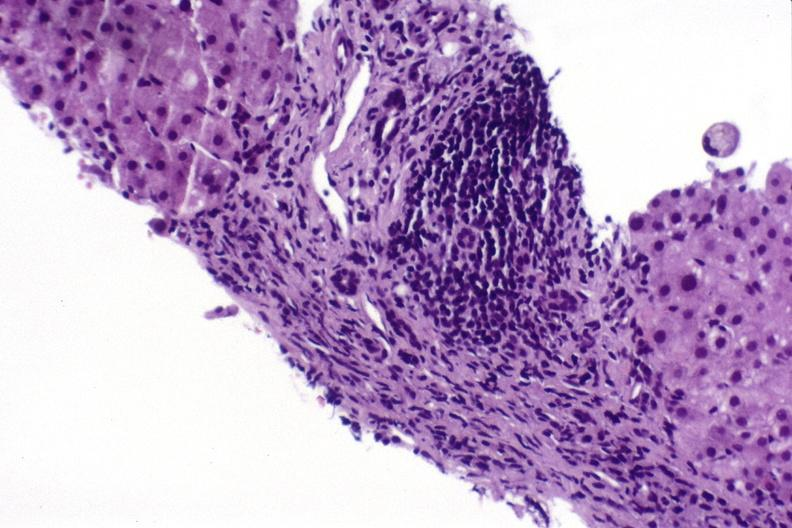what is present?
Answer the question using a single word or phrase. Hepatobiliary 